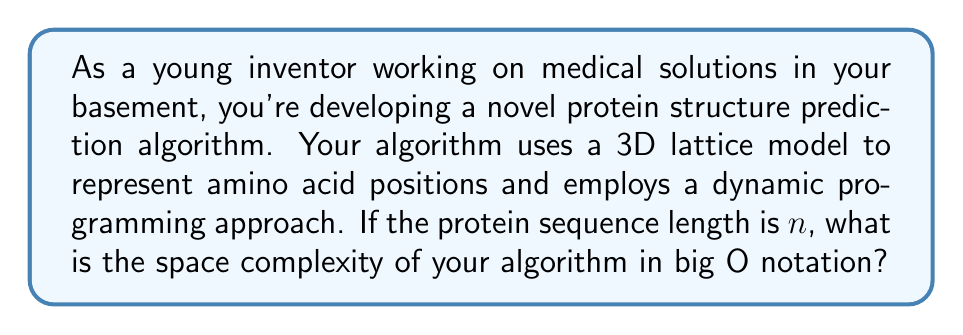Show me your answer to this math problem. To determine the space complexity of the protein structure prediction algorithm, we need to analyze the memory requirements of the dynamic programming approach on a 3D lattice model:

1. 3D Lattice Representation:
   - Each amino acid can occupy a point in a 3D space.
   - For a protein of length $n$, the maximum possible 3D space required is $n \times n \times n = n^3$.

2. Dynamic Programming Table:
   - The DP table needs to store information for each possible subproblem.
   - Subproblems are typically defined by the start and end positions of subsequences.
   - For a sequence of length $n$, there are $O(n^2)$ possible subsequences.

3. State Representation:
   - For each subsequence, we need to store information about its 3D configuration.
   - In the worst case, we might need to store a constant amount of information for each possible 3D position.

4. Combining the factors:
   - Total space required: $O(n^2) \times O(n^3) = O(n^5)$

5. Optimization considerations:
   - In practice, not all $n^3$ positions are valid for each subsequence.
   - Some algorithms use additional pruning techniques to reduce the space complexity.
   - However, without specific optimizations, the worst-case space complexity remains $O(n^5)$.

Therefore, the space complexity of this protein structure prediction algorithm is $O(n^5)$, where $n$ is the length of the protein sequence.
Answer: $O(n^5)$ 